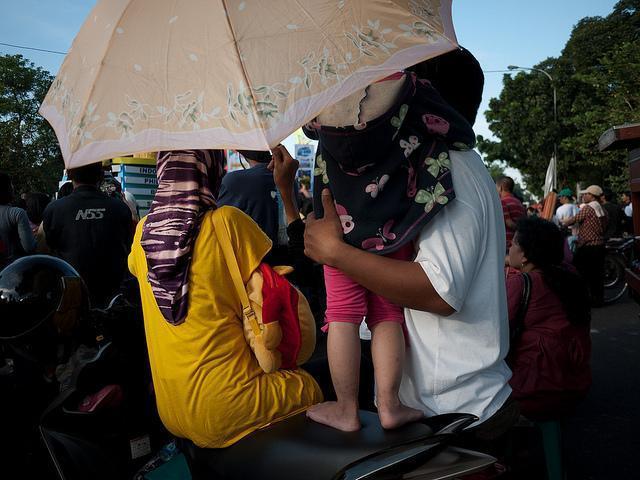How many motorcycles can be seen?
Give a very brief answer. 2. How many people are there?
Give a very brief answer. 8. How many chairs are there?
Give a very brief answer. 0. 